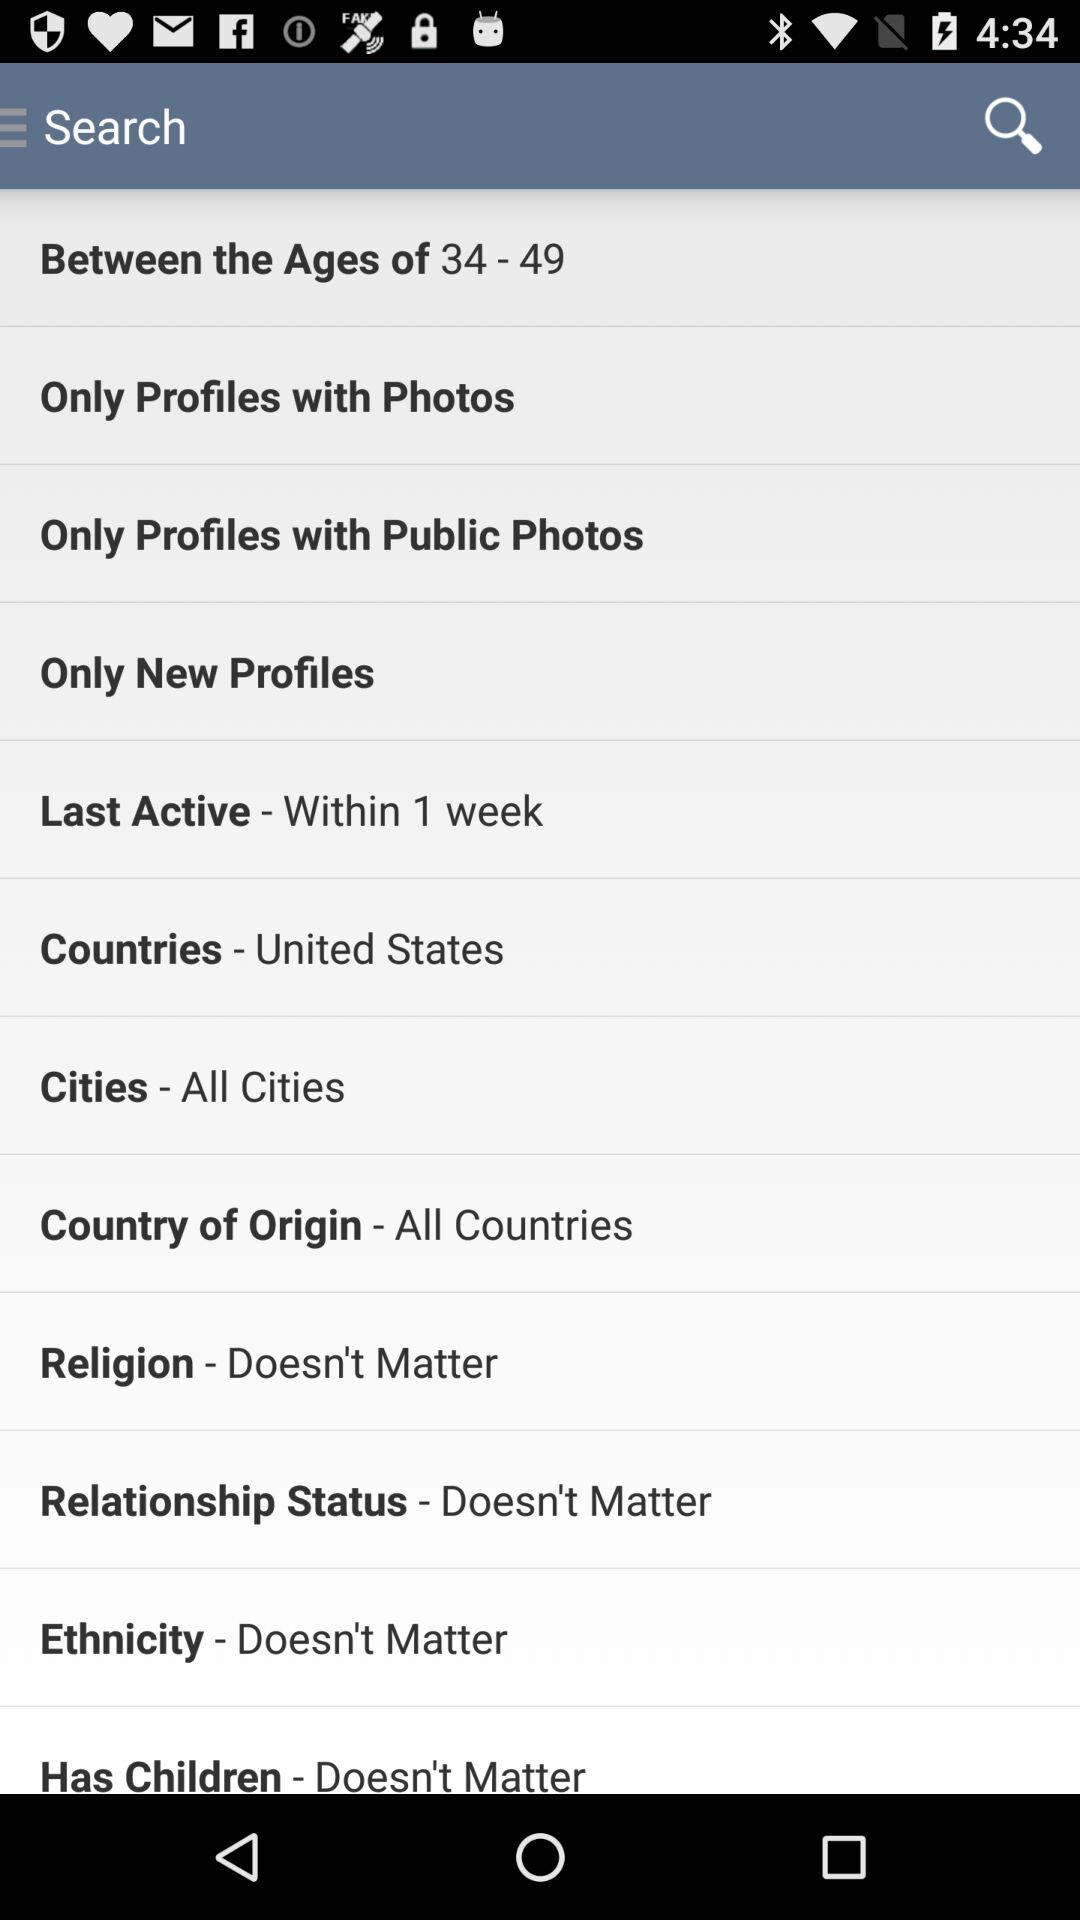What is the relationship status? The relationship status is "Doesn't Matter". 